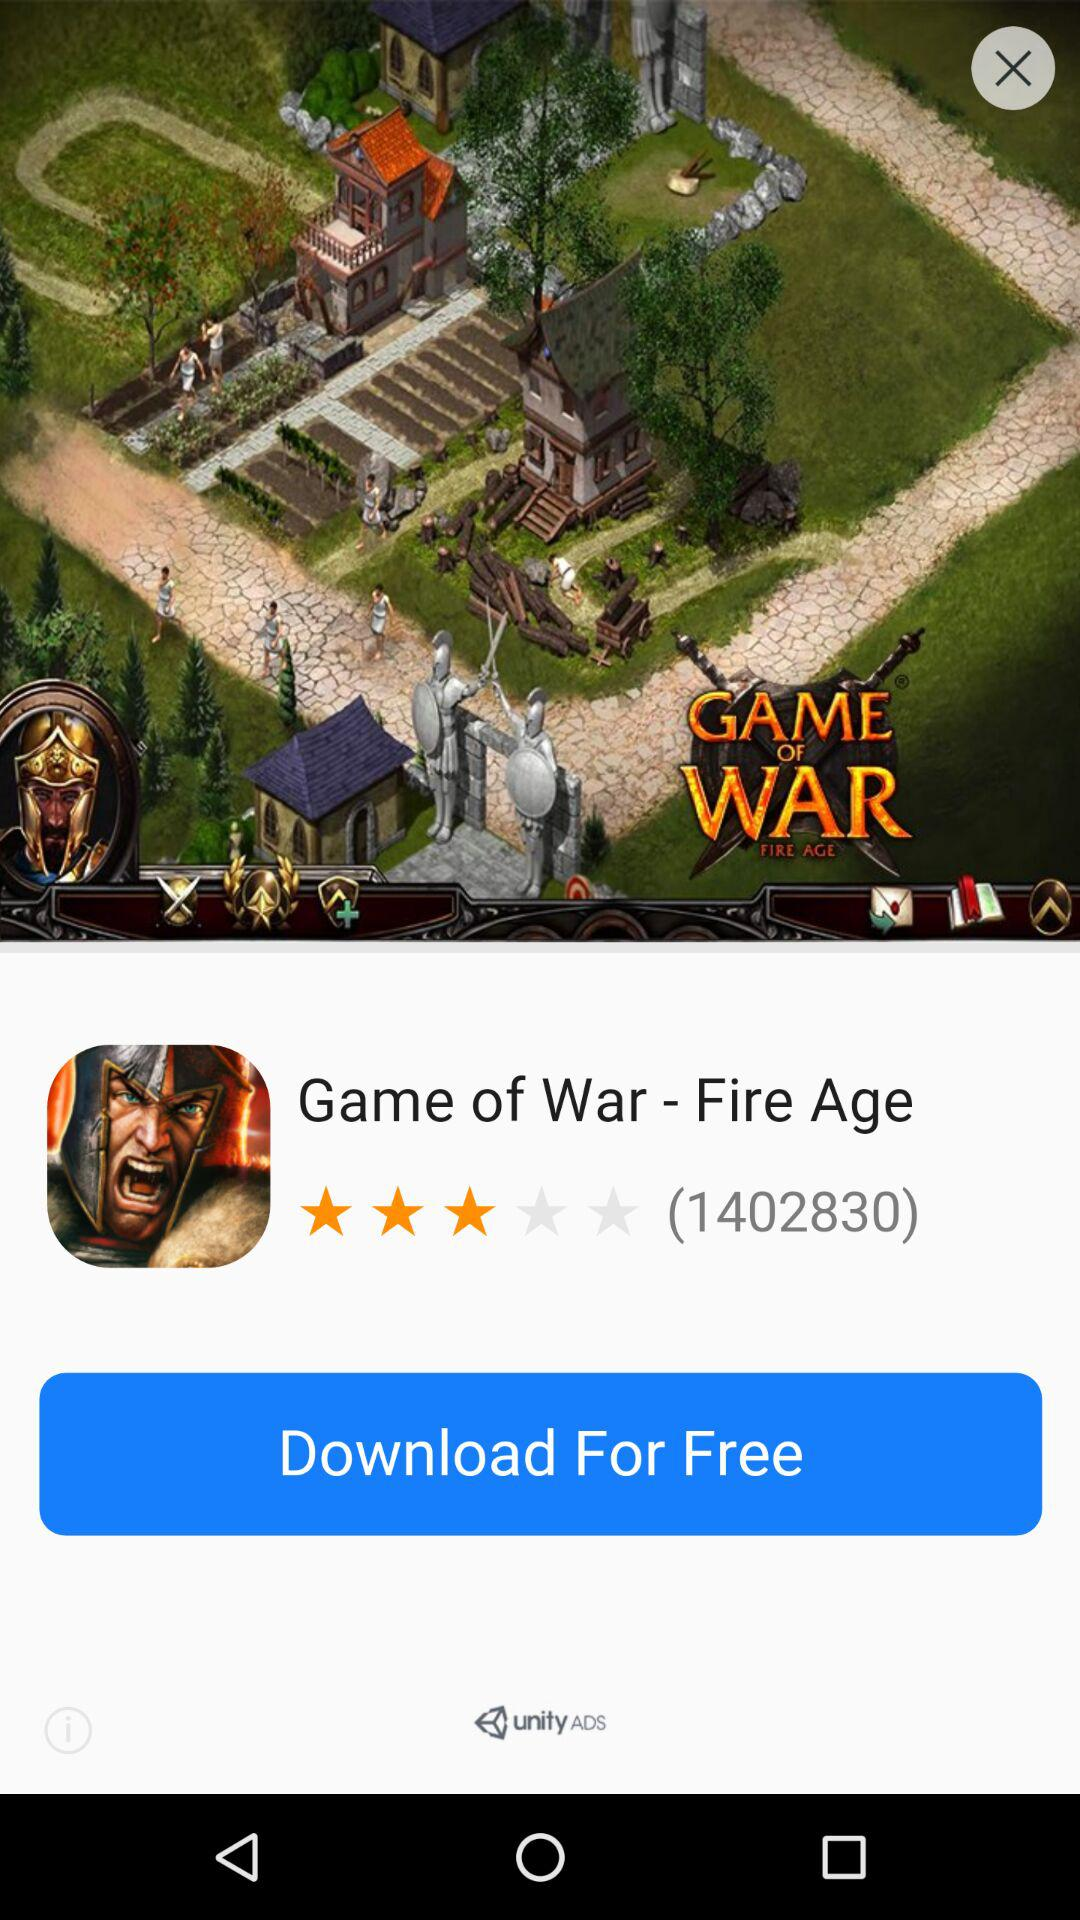What is the rating? The rating is 3 stars. 